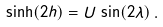Convert formula to latex. <formula><loc_0><loc_0><loc_500><loc_500>\sinh ( 2 h ) = U \, \sin ( 2 \lambda ) \, .</formula> 